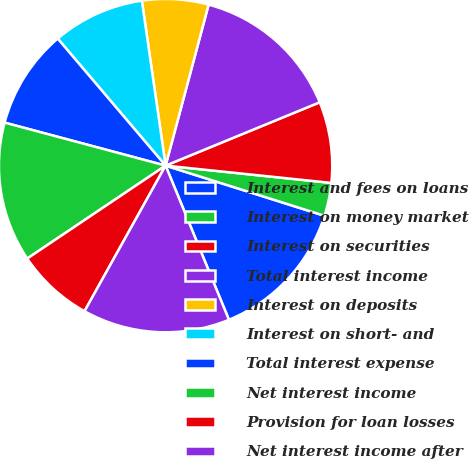Convert chart to OTSL. <chart><loc_0><loc_0><loc_500><loc_500><pie_chart><fcel>Interest and fees on loans<fcel>Interest on money market<fcel>Interest on securities<fcel>Total interest income<fcel>Interest on deposits<fcel>Interest on short- and<fcel>Total interest expense<fcel>Net interest income<fcel>Provision for loan losses<fcel>Net interest income after<nl><fcel>13.93%<fcel>3.21%<fcel>7.86%<fcel>14.64%<fcel>6.43%<fcel>8.93%<fcel>9.64%<fcel>13.57%<fcel>7.5%<fcel>14.29%<nl></chart> 